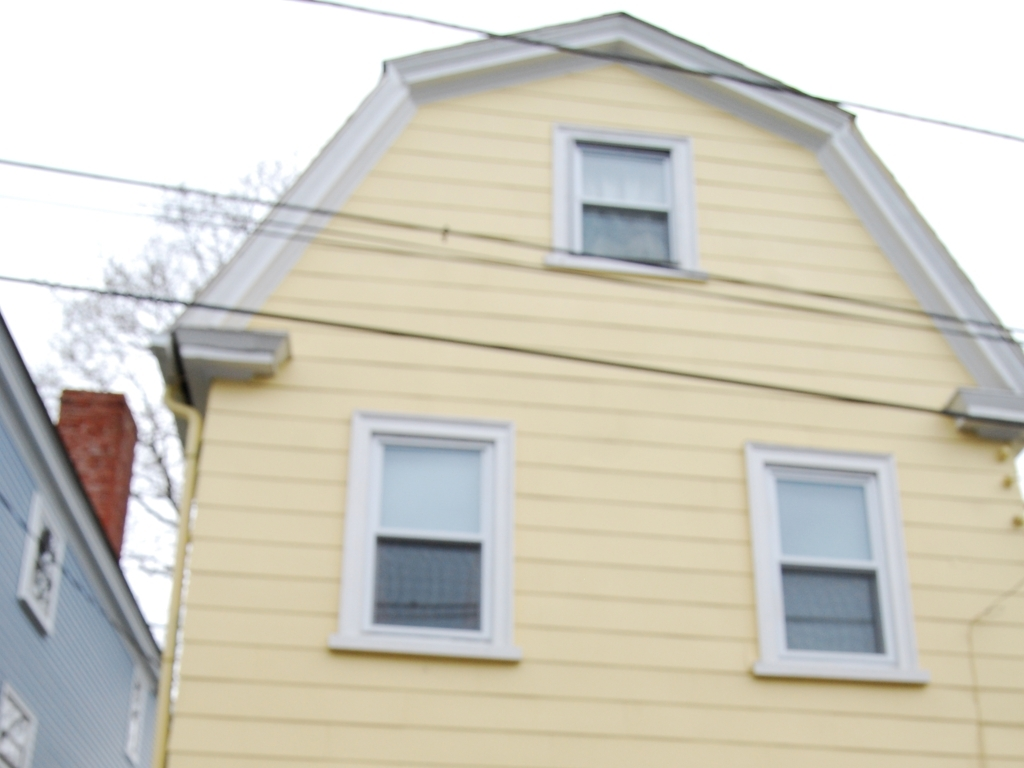Are there power lines obstructing the house?
 Yes 